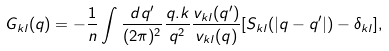Convert formula to latex. <formula><loc_0><loc_0><loc_500><loc_500>G _ { k l } ( q ) = - \frac { 1 } { n } \int \frac { d { q ^ { \prime } } } { ( 2 \pi ) ^ { 2 } } \frac { q . k } { q ^ { 2 } } \frac { v _ { k l } ( q ^ { \prime } ) } { v _ { k l } ( q ) } [ S _ { k l } ( | { q - q ^ { \prime } } | ) - \delta _ { k l } ] ,</formula> 